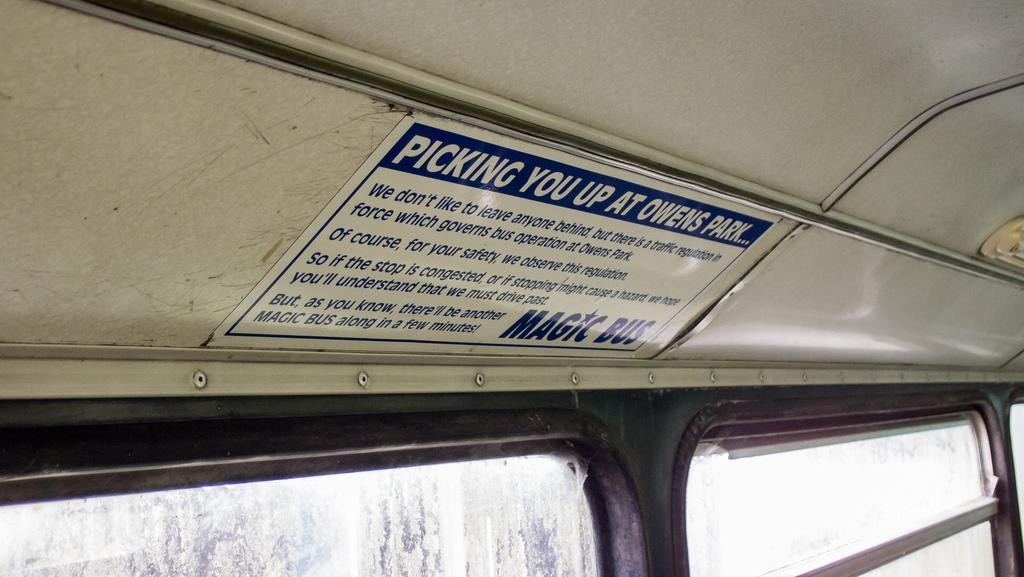Please provide a concise description of this image. This picture is clicked inside the bus. At the bottom of the picture, we see windows. In the middle of the picture, we see the poster with text written is pasted on top of the bus. 